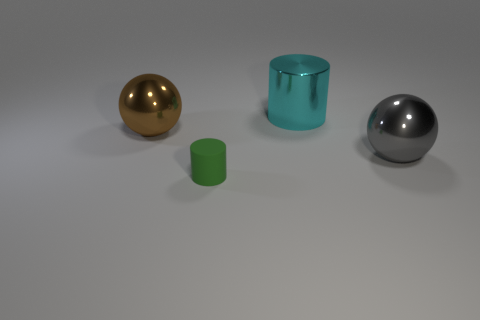Is the shape of the green rubber thing the same as the big cyan metallic thing?
Make the answer very short. Yes. How many small things are rubber things or metallic spheres?
Provide a succinct answer. 1. Are there more small matte cylinders than big blue cubes?
Provide a short and direct response. Yes. There is a gray object that is the same material as the brown object; what is its size?
Make the answer very short. Large. Do the cylinder in front of the brown thing and the shiny object left of the tiny green rubber thing have the same size?
Your answer should be very brief. No. How many objects are gray shiny things that are on the right side of the large cyan object or tiny green rubber objects?
Provide a short and direct response. 2. Are there fewer big shiny balls than large brown metallic balls?
Your answer should be compact. No. The shiny object in front of the ball that is behind the big thing right of the cyan cylinder is what shape?
Give a very brief answer. Sphere. Are there any small brown matte cylinders?
Your answer should be compact. No. Does the cyan object have the same size as the ball on the left side of the green object?
Offer a very short reply. Yes. 